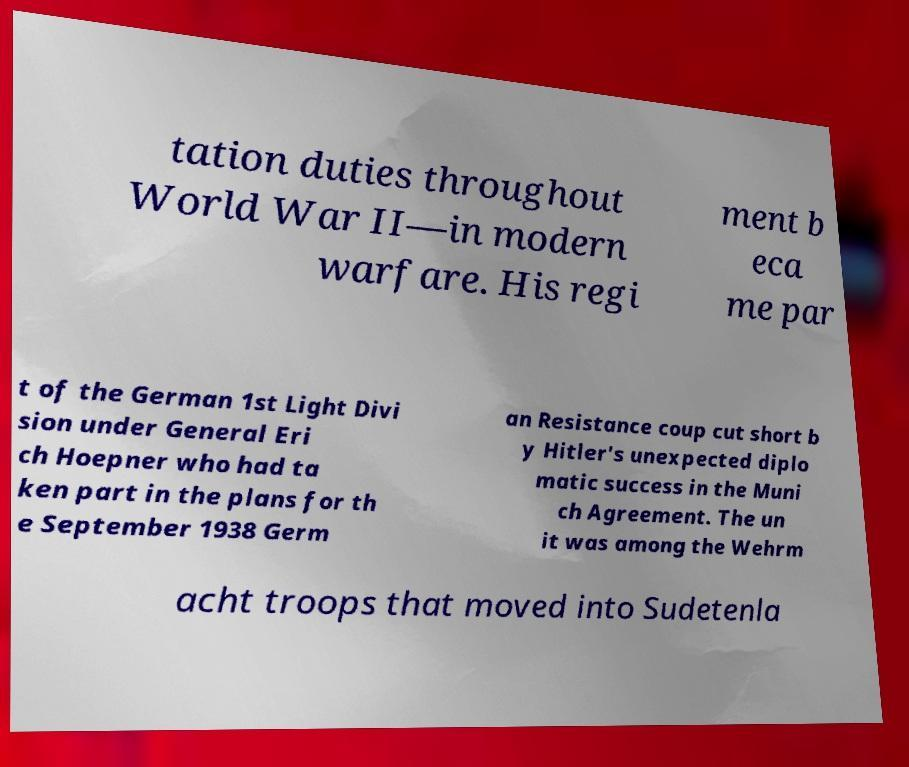What messages or text are displayed in this image? I need them in a readable, typed format. tation duties throughout World War II—in modern warfare. His regi ment b eca me par t of the German 1st Light Divi sion under General Eri ch Hoepner who had ta ken part in the plans for th e September 1938 Germ an Resistance coup cut short b y Hitler's unexpected diplo matic success in the Muni ch Agreement. The un it was among the Wehrm acht troops that moved into Sudetenla 